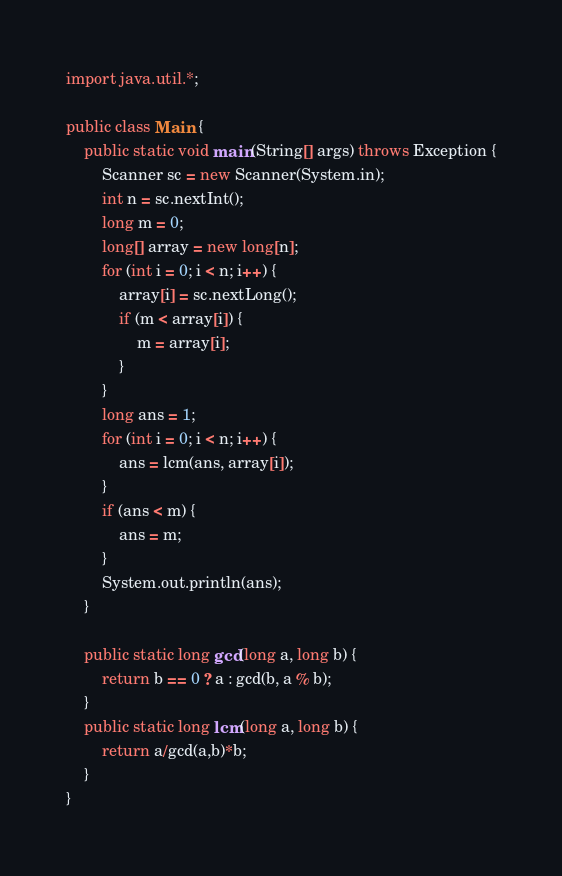<code> <loc_0><loc_0><loc_500><loc_500><_Java_>import java.util.*;

public class Main {
    public static void main(String[] args) throws Exception {
        Scanner sc = new Scanner(System.in);
        int n = sc.nextInt();
        long m = 0;
        long[] array = new long[n];
        for (int i = 0; i < n; i++) {
            array[i] = sc.nextLong();
            if (m < array[i]) {
                m = array[i];
            }
        }
        long ans = 1;
        for (int i = 0; i < n; i++) {
            ans = lcm(ans, array[i]);
        }
        if (ans < m) {
            ans = m;
        }
        System.out.println(ans);
    }
    
    public static long gcd(long a, long b) {
        return b == 0 ? a : gcd(b, a % b);
    }
    public static long lcm(long a, long b) {
        return a/gcd(a,b)*b;
    }
}
</code> 